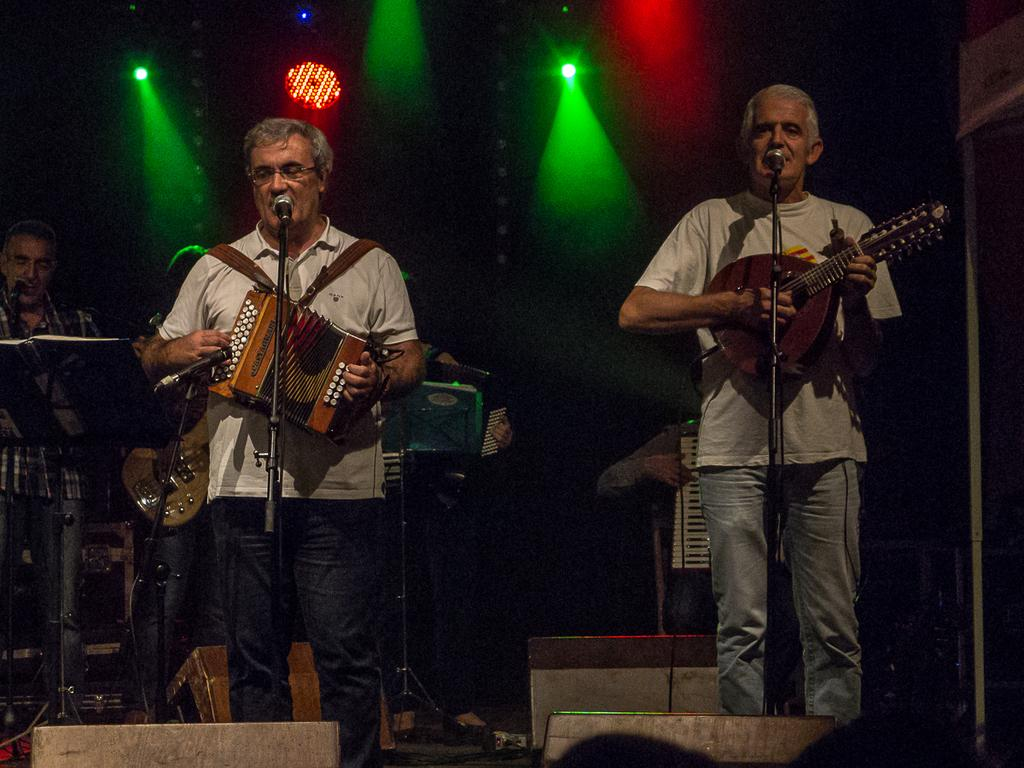What is happening in the image involving the group of people? The people in the image are holding musical instruments. What objects are in front of the people? There are microphones in front of the people. What can be seen in the background of the image? Colorful lights are visible in the background of the image. What type of writing can be seen on the record in the image? There is no record present in the image; the people are holding musical instruments and there are microphones in front of them. 